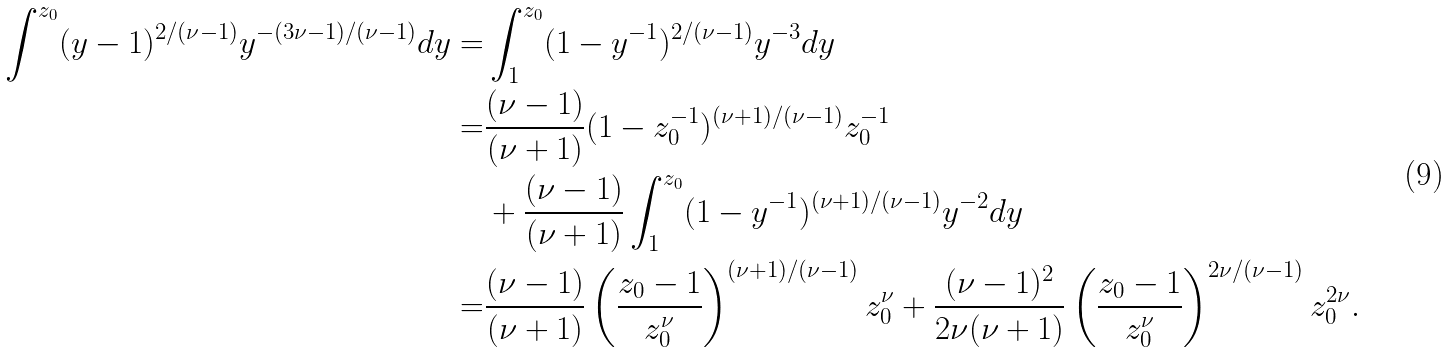<formula> <loc_0><loc_0><loc_500><loc_500>\int ^ { z _ { 0 } } ( y - 1 ) ^ { 2 / ( \nu - 1 ) } y ^ { - ( 3 \nu - 1 ) / ( \nu - 1 ) } d y = & \int _ { 1 } ^ { z _ { 0 } } ( 1 - y ^ { - 1 } ) ^ { 2 / ( \nu - 1 ) } y ^ { - 3 } d y \\ = & \frac { ( \nu - 1 ) } { ( \nu + 1 ) } ( 1 - z _ { 0 } ^ { - 1 } ) ^ { ( \nu + 1 ) / ( \nu - 1 ) } z _ { 0 } ^ { - 1 } \\ & + \frac { ( \nu - 1 ) } { ( \nu + 1 ) } \int _ { 1 } ^ { z _ { 0 } } ( 1 - y ^ { - 1 } ) ^ { ( \nu + 1 ) / ( \nu - 1 ) } y ^ { - 2 } d y \\ = & \frac { ( \nu - 1 ) } { ( \nu + 1 ) } \left ( \frac { z _ { 0 } - 1 } { z _ { 0 } ^ { \nu } } \right ) ^ { ( \nu + 1 ) / ( \nu - 1 ) } z _ { 0 } ^ { \nu } + \frac { ( \nu - 1 ) ^ { 2 } } { 2 \nu ( \nu + 1 ) } \left ( \frac { z _ { 0 } - 1 } { z _ { 0 } ^ { \nu } } \right ) ^ { 2 \nu / ( \nu - 1 ) } z _ { 0 } ^ { 2 \nu } .</formula> 